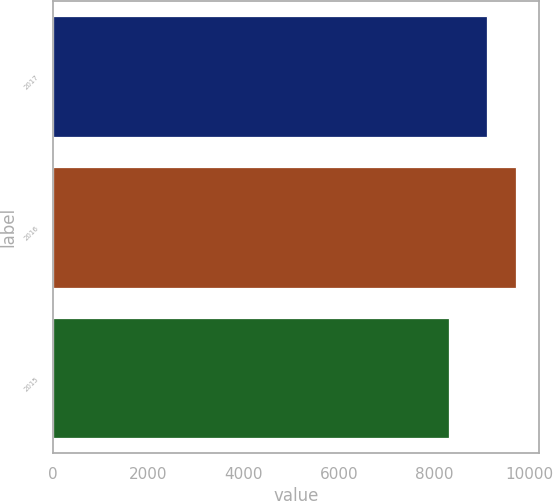Convert chart to OTSL. <chart><loc_0><loc_0><loc_500><loc_500><bar_chart><fcel>2017<fcel>2016<fcel>2015<nl><fcel>9111<fcel>9713<fcel>8307<nl></chart> 